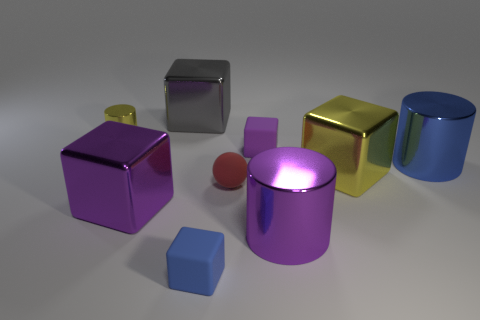Subtract all yellow cubes. How many cubes are left? 4 Subtract all yellow blocks. How many blocks are left? 4 Subtract all cyan blocks. Subtract all cyan balls. How many blocks are left? 5 Subtract all cylinders. How many objects are left? 6 Subtract all red matte things. Subtract all small cyan things. How many objects are left? 8 Add 3 gray cubes. How many gray cubes are left? 4 Add 8 gray metallic things. How many gray metallic things exist? 9 Subtract 1 blue cylinders. How many objects are left? 8 